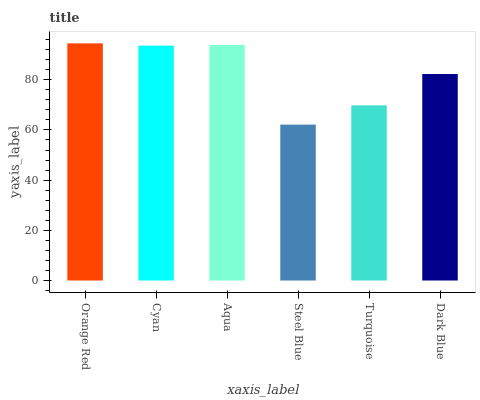Is Steel Blue the minimum?
Answer yes or no. Yes. Is Orange Red the maximum?
Answer yes or no. Yes. Is Cyan the minimum?
Answer yes or no. No. Is Cyan the maximum?
Answer yes or no. No. Is Orange Red greater than Cyan?
Answer yes or no. Yes. Is Cyan less than Orange Red?
Answer yes or no. Yes. Is Cyan greater than Orange Red?
Answer yes or no. No. Is Orange Red less than Cyan?
Answer yes or no. No. Is Cyan the high median?
Answer yes or no. Yes. Is Dark Blue the low median?
Answer yes or no. Yes. Is Orange Red the high median?
Answer yes or no. No. Is Steel Blue the low median?
Answer yes or no. No. 